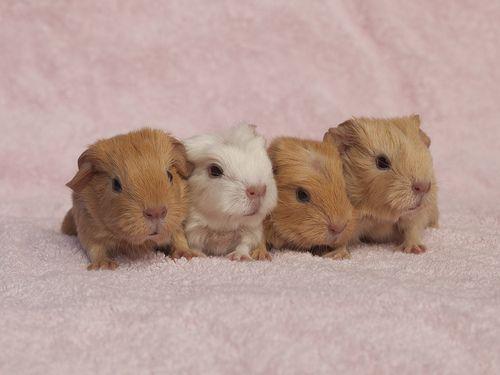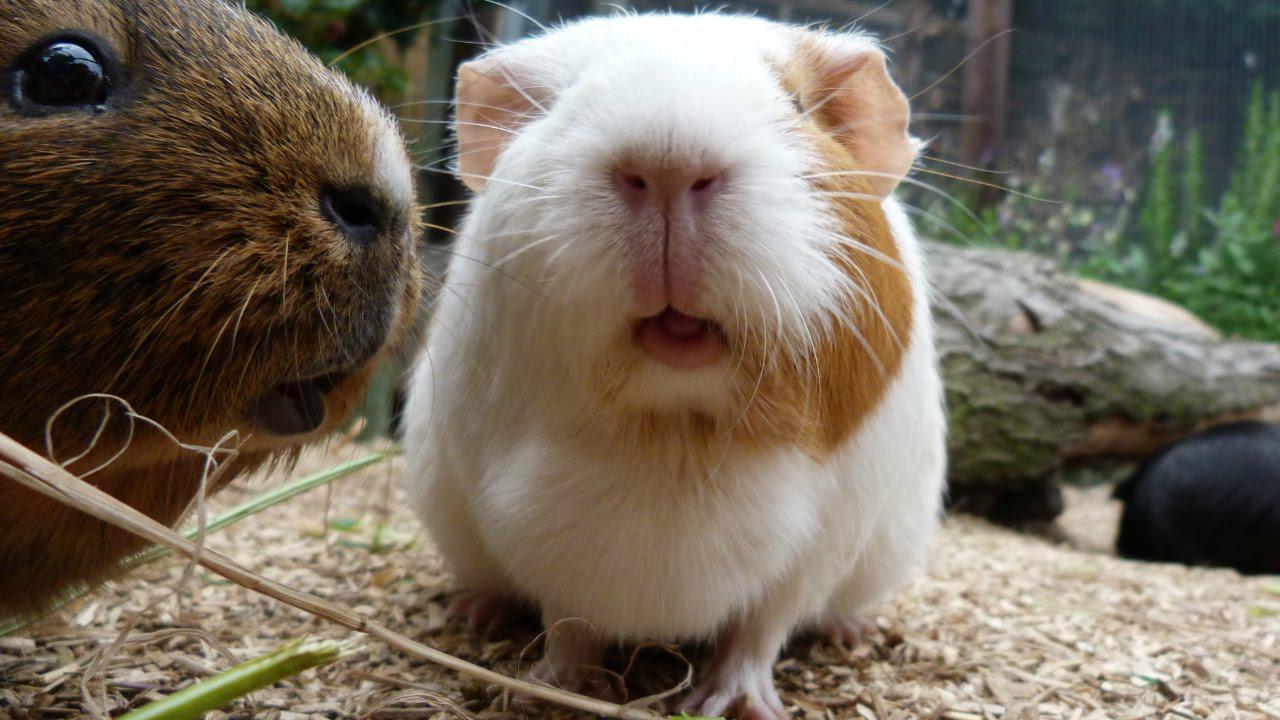The first image is the image on the left, the second image is the image on the right. For the images displayed, is the sentence "An image shows an extended hand holding at least one hamster." factually correct? Answer yes or no. No. The first image is the image on the left, the second image is the image on the right. Evaluate the accuracy of this statement regarding the images: "In one image, at least one rodent is being held in a human hand". Is it true? Answer yes or no. No. 